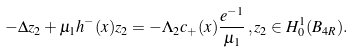Convert formula to latex. <formula><loc_0><loc_0><loc_500><loc_500>- \Delta z _ { 2 } + \mu _ { 1 } h ^ { - } ( x ) z _ { 2 } = - \Lambda _ { 2 } c _ { + } ( x ) \frac { e ^ { - 1 } } { \mu _ { 1 } } \, , z _ { 2 } \in H ^ { 1 } _ { 0 } ( B _ { 4 R } ) .</formula> 